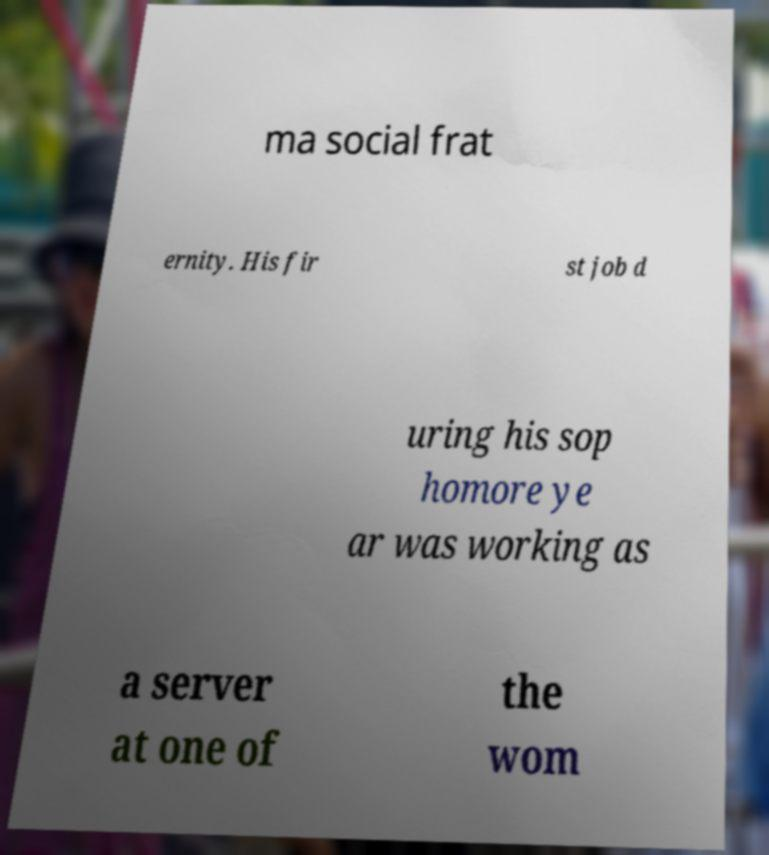Could you assist in decoding the text presented in this image and type it out clearly? ma social frat ernity. His fir st job d uring his sop homore ye ar was working as a server at one of the wom 